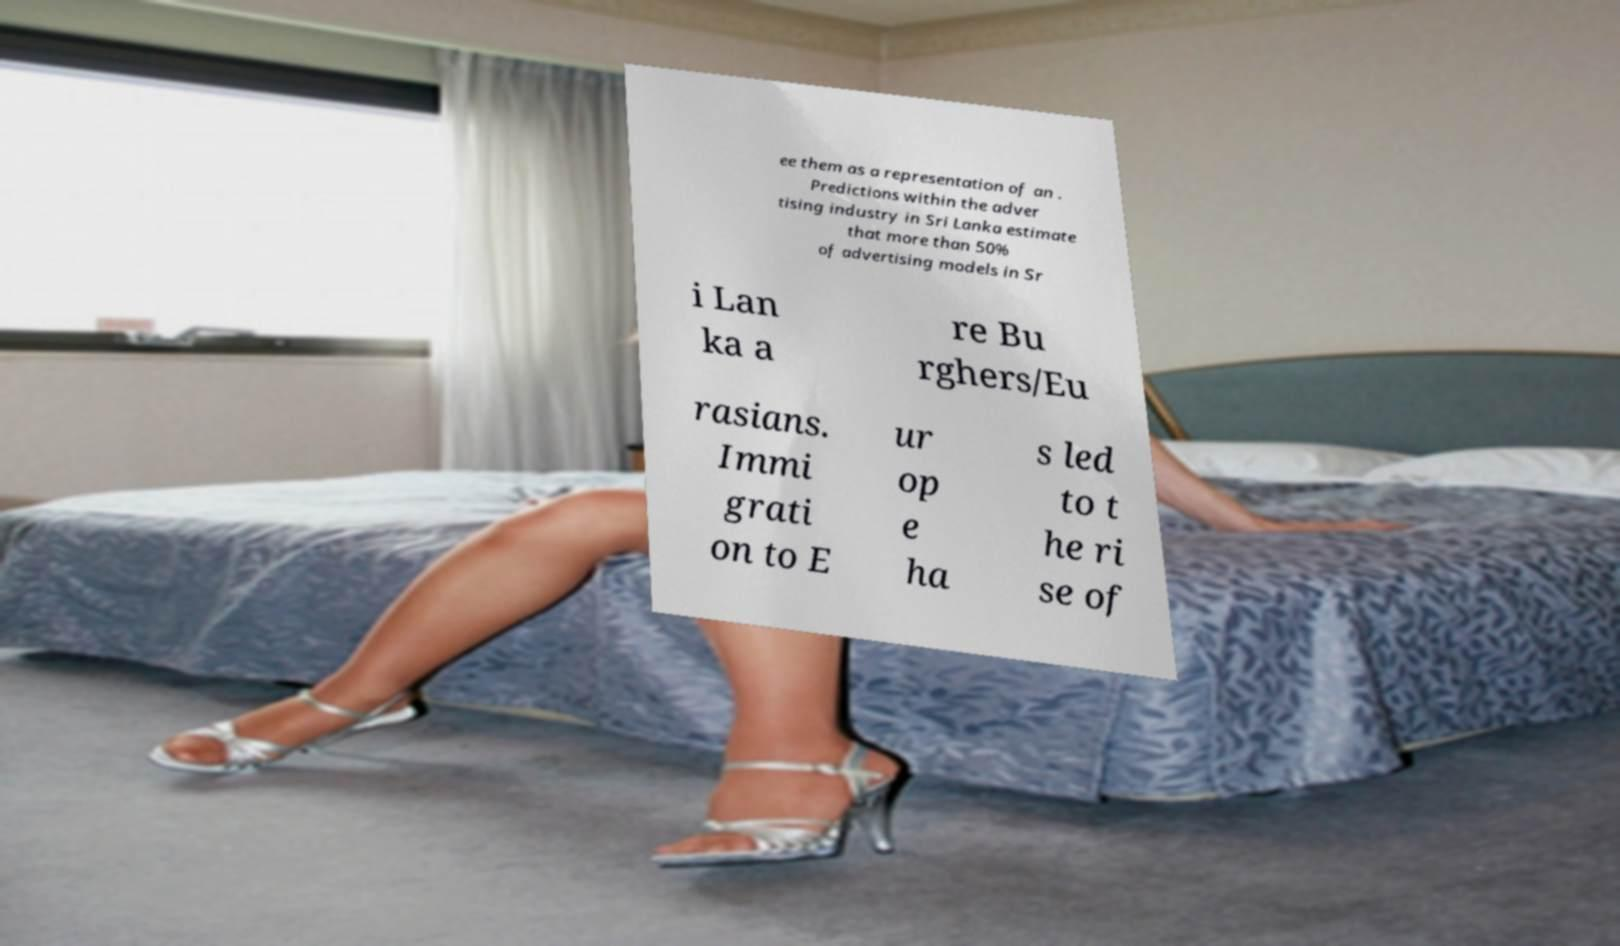Could you extract and type out the text from this image? ee them as a representation of an . Predictions within the adver tising industry in Sri Lanka estimate that more than 50% of advertising models in Sr i Lan ka a re Bu rghers/Eu rasians. Immi grati on to E ur op e ha s led to t he ri se of 